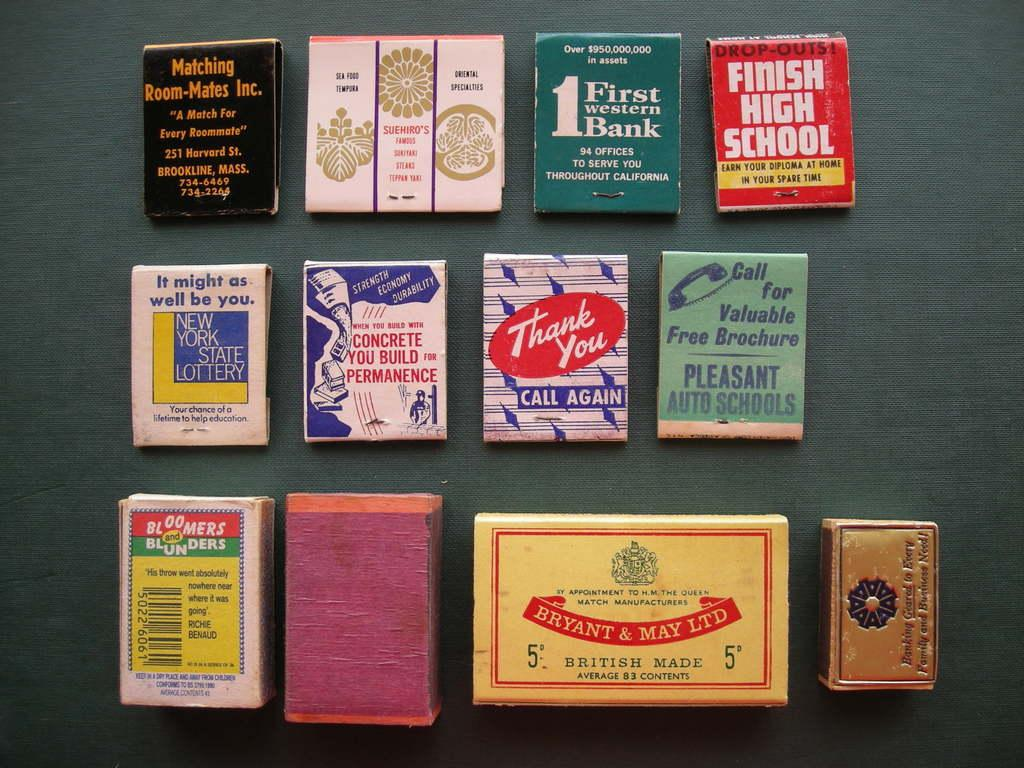Provide a one-sentence caption for the provided image. A collection of matchbooks from places like the Finish High School and First Western Bank on display. 